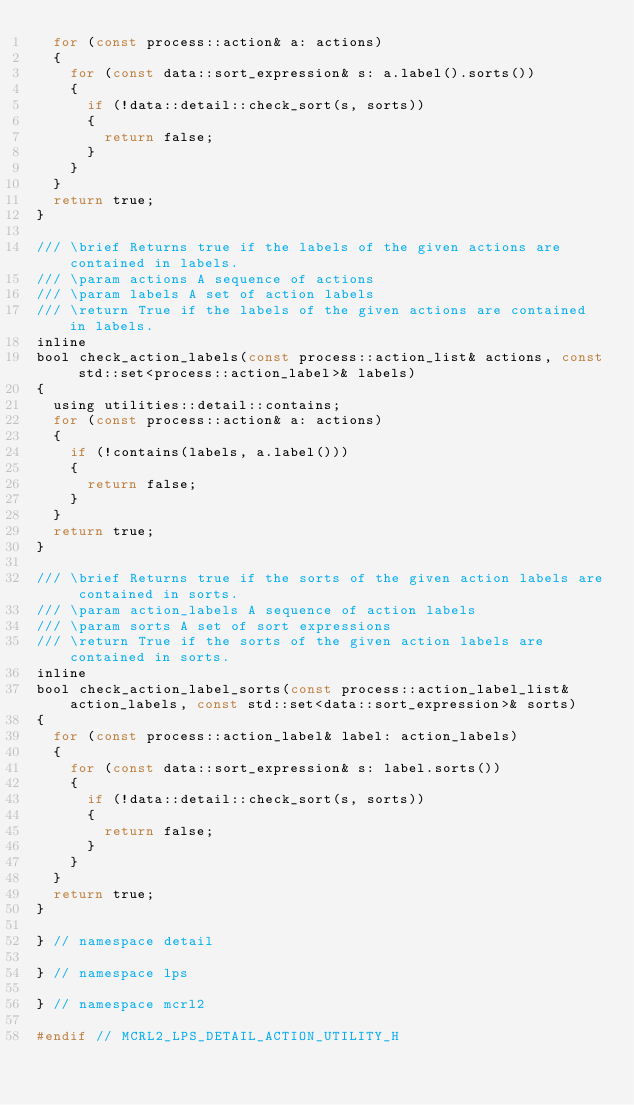Convert code to text. <code><loc_0><loc_0><loc_500><loc_500><_C_>  for (const process::action& a: actions)
  {
    for (const data::sort_expression& s: a.label().sorts())
    {
      if (!data::detail::check_sort(s, sorts))
      {
        return false;
      }
    }
  }
  return true;
}

/// \brief Returns true if the labels of the given actions are contained in labels.
/// \param actions A sequence of actions
/// \param labels A set of action labels
/// \return True if the labels of the given actions are contained in labels.
inline
bool check_action_labels(const process::action_list& actions, const std::set<process::action_label>& labels)
{
  using utilities::detail::contains;
  for (const process::action& a: actions)
  {
    if (!contains(labels, a.label()))
    {
      return false;
    }
  }
  return true;
}

/// \brief Returns true if the sorts of the given action labels are contained in sorts.
/// \param action_labels A sequence of action labels
/// \param sorts A set of sort expressions
/// \return True if the sorts of the given action labels are contained in sorts.
inline
bool check_action_label_sorts(const process::action_label_list& action_labels, const std::set<data::sort_expression>& sorts)
{
  for (const process::action_label& label: action_labels)
  {
    for (const data::sort_expression& s: label.sorts())
    {
      if (!data::detail::check_sort(s, sorts))
      {
        return false;
      }
    }
  }
  return true;
}

} // namespace detail

} // namespace lps

} // namespace mcrl2

#endif // MCRL2_LPS_DETAIL_ACTION_UTILITY_H
</code> 